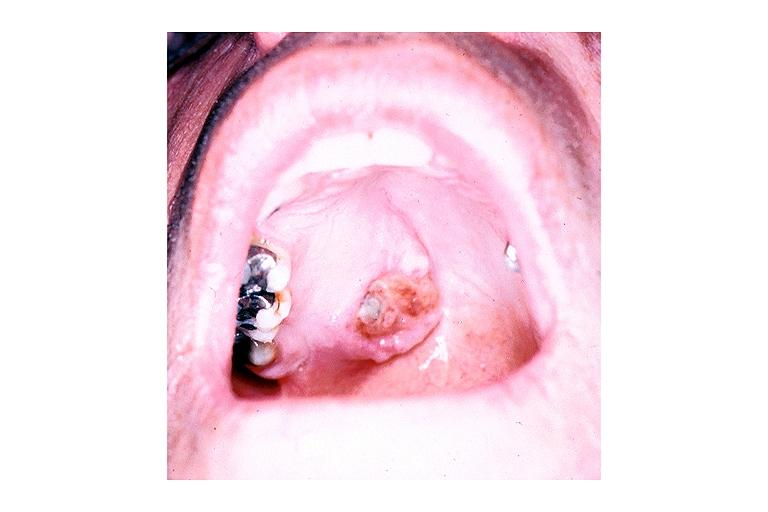where is this?
Answer the question using a single word or phrase. Oral 